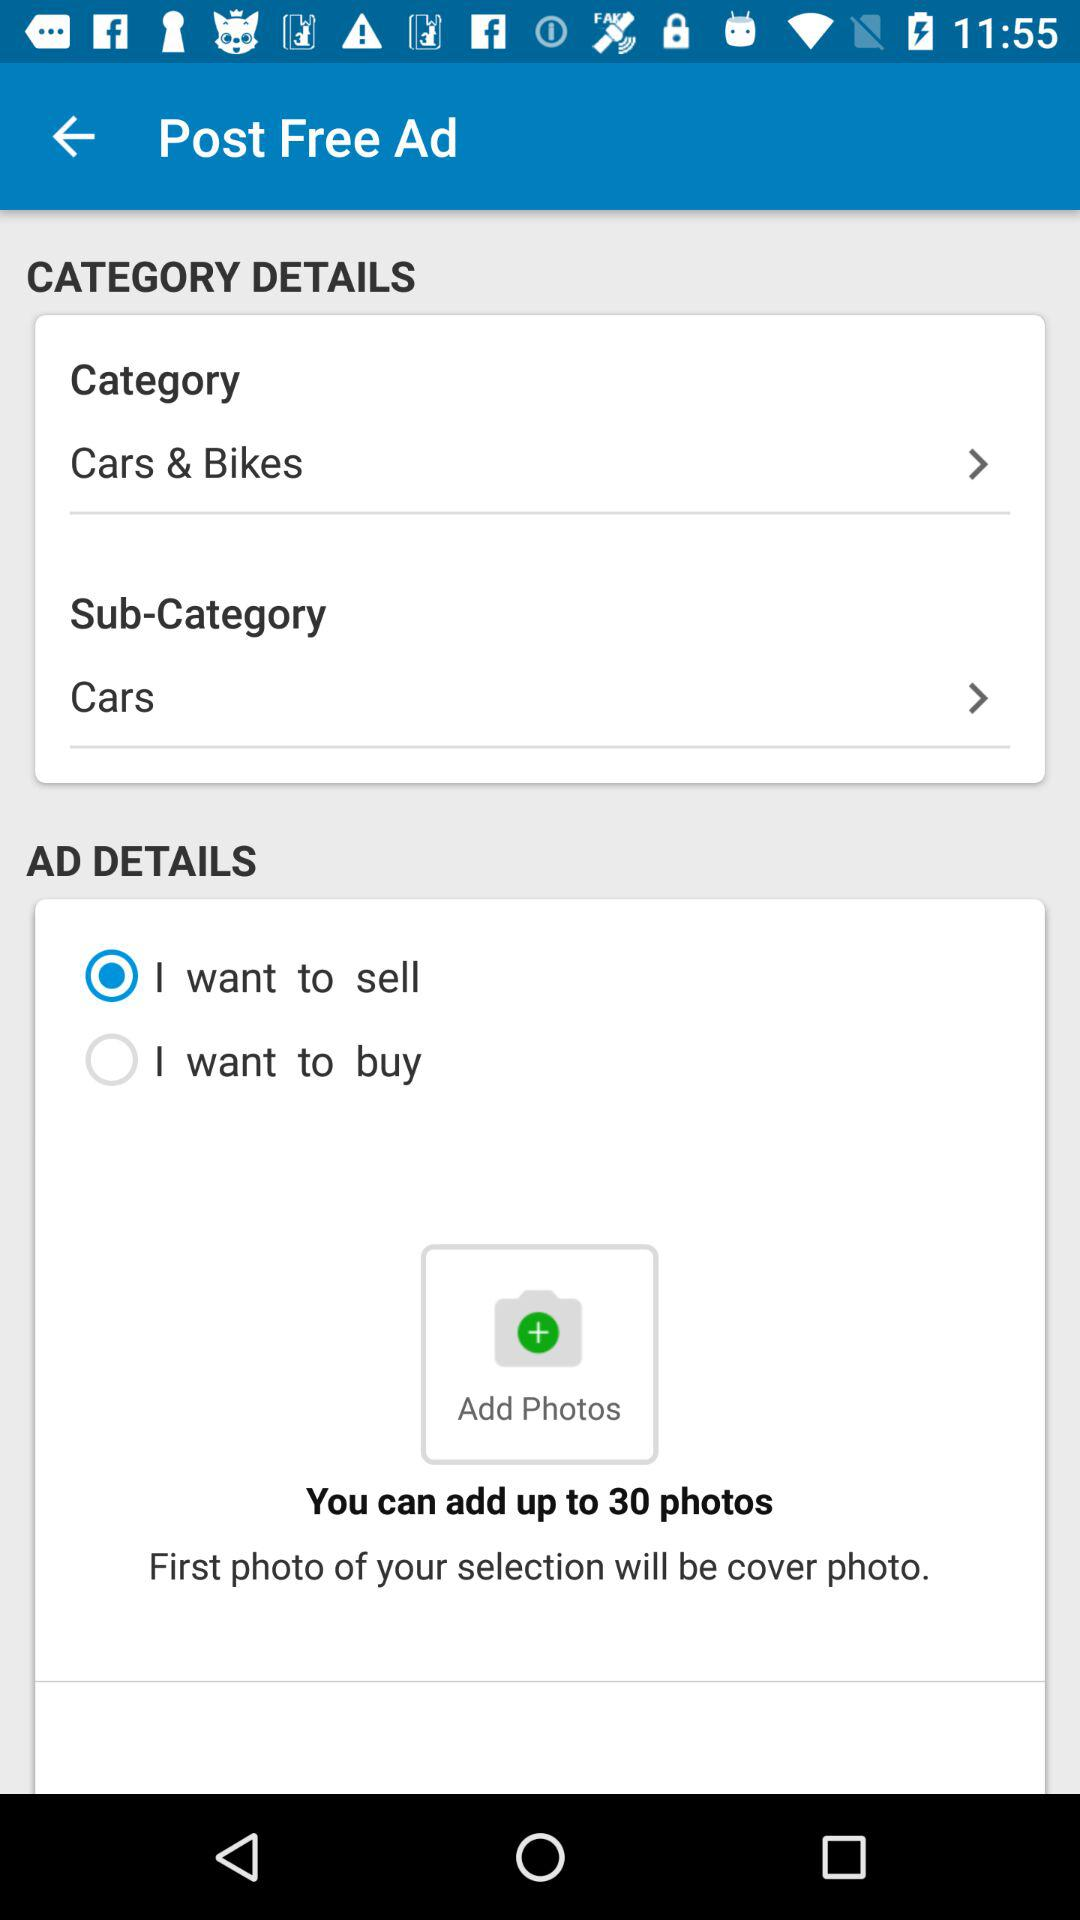What is the selected category? The selected category is "Cars & Bikes". 